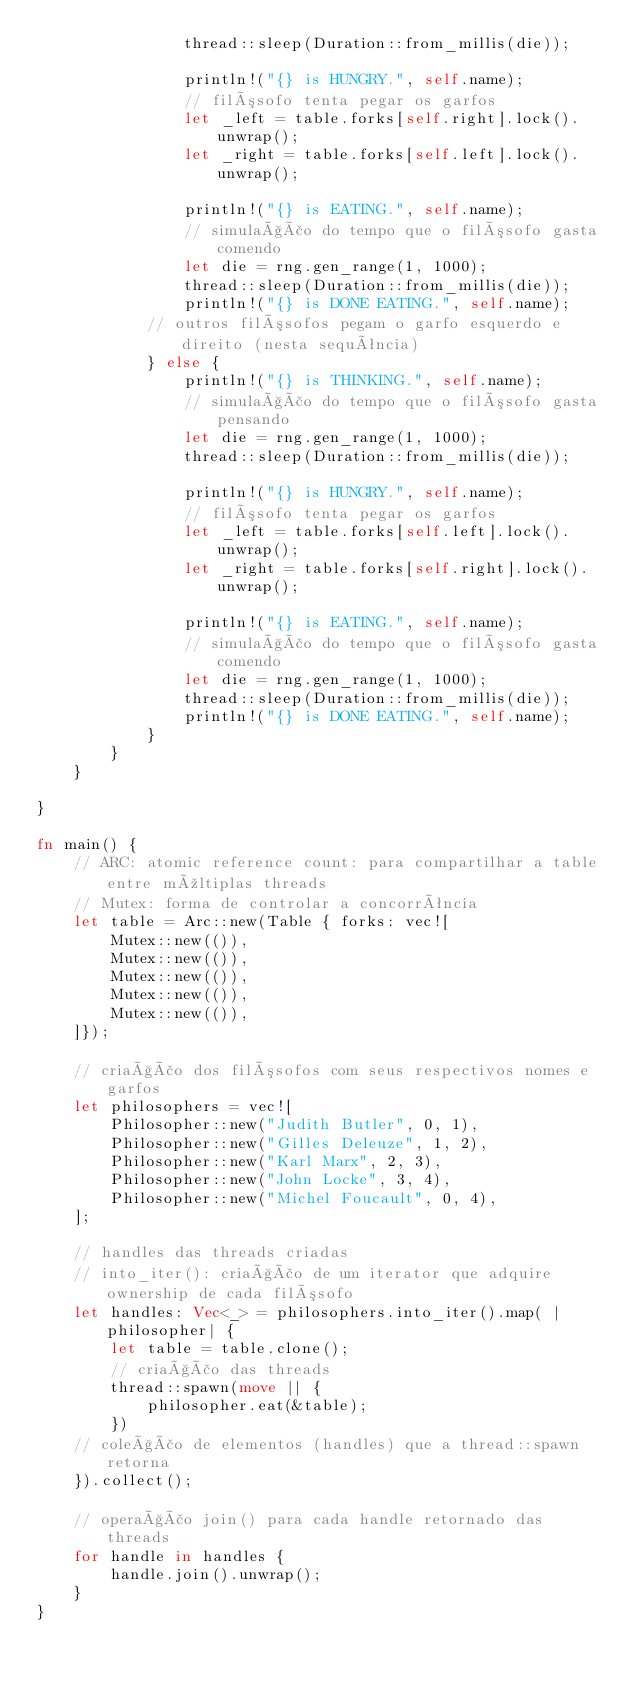Convert code to text. <code><loc_0><loc_0><loc_500><loc_500><_Rust_>                thread::sleep(Duration::from_millis(die));

                println!("{} is HUNGRY.", self.name);
                // filósofo tenta pegar os garfos
                let _left = table.forks[self.right].lock().unwrap();
                let _right = table.forks[self.left].lock().unwrap();

                println!("{} is EATING.", self.name);
                // simulação do tempo que o filósofo gasta comendo
                let die = rng.gen_range(1, 1000);
                thread::sleep(Duration::from_millis(die));
                println!("{} is DONE EATING.", self.name);
            // outros filósofos pegam o garfo esquerdo e direito (nesta sequência)
            } else {
                println!("{} is THINKING.", self.name);
                // simulação do tempo que o filósofo gasta pensando
                let die = rng.gen_range(1, 1000);
                thread::sleep(Duration::from_millis(die));

                println!("{} is HUNGRY.", self.name);
                // filósofo tenta pegar os garfos
                let _left = table.forks[self.left].lock().unwrap();
                let _right = table.forks[self.right].lock().unwrap();

                println!("{} is EATING.", self.name);
                // simulação do tempo que o filósofo gasta comendo
                let die = rng.gen_range(1, 1000);
                thread::sleep(Duration::from_millis(die));
                println!("{} is DONE EATING.", self.name);
            }
        }
    }

}

fn main() {
    // ARC: atomic reference count: para compartilhar a table entre múltiplas threads
    // Mutex: forma de controlar a concorrência
    let table = Arc::new(Table { forks: vec![
        Mutex::new(()),
        Mutex::new(()),
        Mutex::new(()),
        Mutex::new(()),
        Mutex::new(()),
    ]});

    // criação dos filósofos com seus respectivos nomes e garfos
    let philosophers = vec![
        Philosopher::new("Judith Butler", 0, 1),
        Philosopher::new("Gilles Deleuze", 1, 2),
        Philosopher::new("Karl Marx", 2, 3),
        Philosopher::new("John Locke", 3, 4),
        Philosopher::new("Michel Foucault", 0, 4),
    ];

    // handles das threads criadas
    // into_iter(): criação de um iterator que adquire ownership de cada filósofo
    let handles: Vec<_> = philosophers.into_iter().map( |philosopher| {
        let table = table.clone();
        // criação das threads
        thread::spawn(move || {
            philosopher.eat(&table);
        })
    // coleção de elementos (handles) que a thread::spawn retorna
    }).collect();

    // operação join() para cada handle retornado das threads
    for handle in handles {
        handle.join().unwrap();
    }
}
</code> 